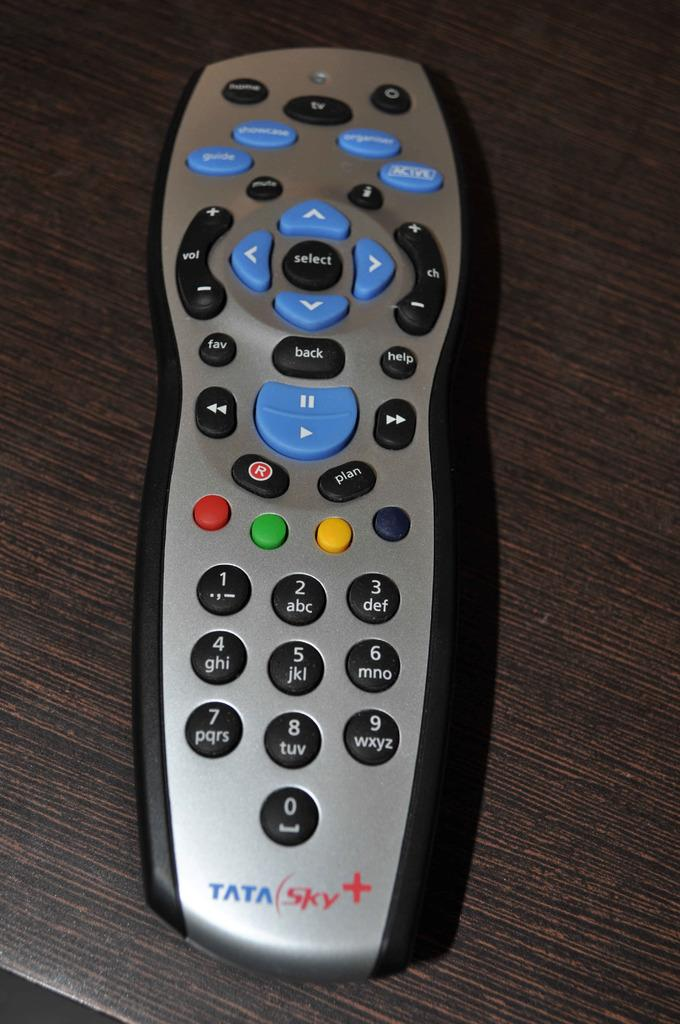Provide a one-sentence caption for the provided image. Tata Sky plus tv remote with buttons to work the television. 